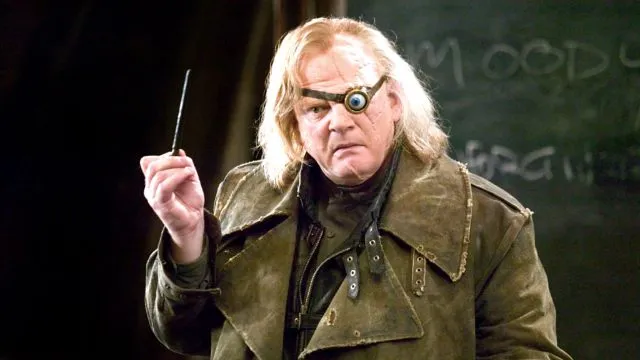If this scene were part of a story, what might be happening? Imagine this: Mad-Eye Moody stands before a group of young wizards, his intense gaze piercing through them. Holding his wand aloft, he demonstrates a complex defensive spell, illustrating the dangers they may face. The classroom is silent, all eyes fixed on Moody, absorbing every word of his hard-earned wisdom. The blackboard behind him lists key points of survival in the wizarding world, emphasizing constant vigilance. This scene captures the essence of a life-or-death lesson, with Moody's battle-hardened demeanor and authoritative presence ensuring the gravity of the lesson sinks in deeply. If the character had a magical pet, what would it be and how would it contribute to his persona? Mad-Eye Moody might be accompanied by a magical creature such as a Thestral, an elusive and skeletal winged horse visible only to those who have witnessed death. The Thestral, symbolizing the sombre realities Moody has faced, would follow him silently, a constant reminder of his many battles and losses. Its presence would add a haunting and solemn depth to his character, underlining the gravity and seriousness with which he approaches his duties. Together, they would present a formidable picture of vigilance and the harsh truths of the magical world. 